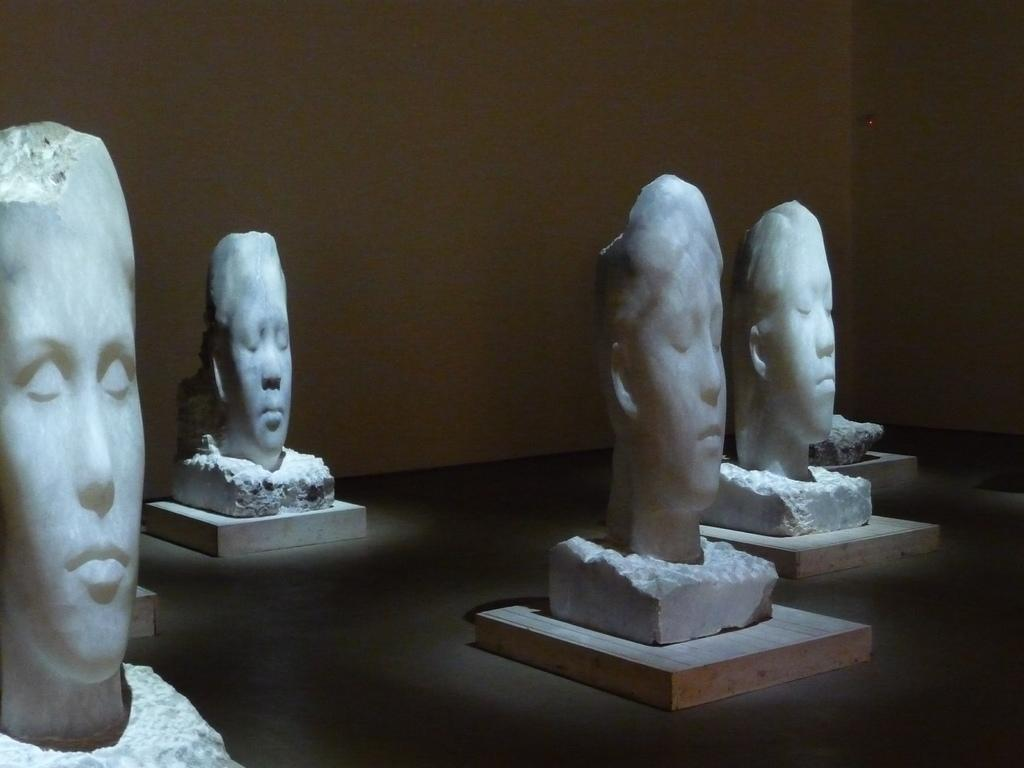What type of art is depicted in the image? There are sculptures of persons' faces in the image. What material are the sculptures mounted on? The sculptures are on wooden boards. What can be seen in the background of the image? There is a wall in the background of the image. What is the temperature of the wooden boards in the image? The temperature of the wooden boards cannot be determined from the image. How many masses are present in the image? There is no mention of masses in the image; it features sculptures of persons' faces on wooden boards with a wall in the background. 